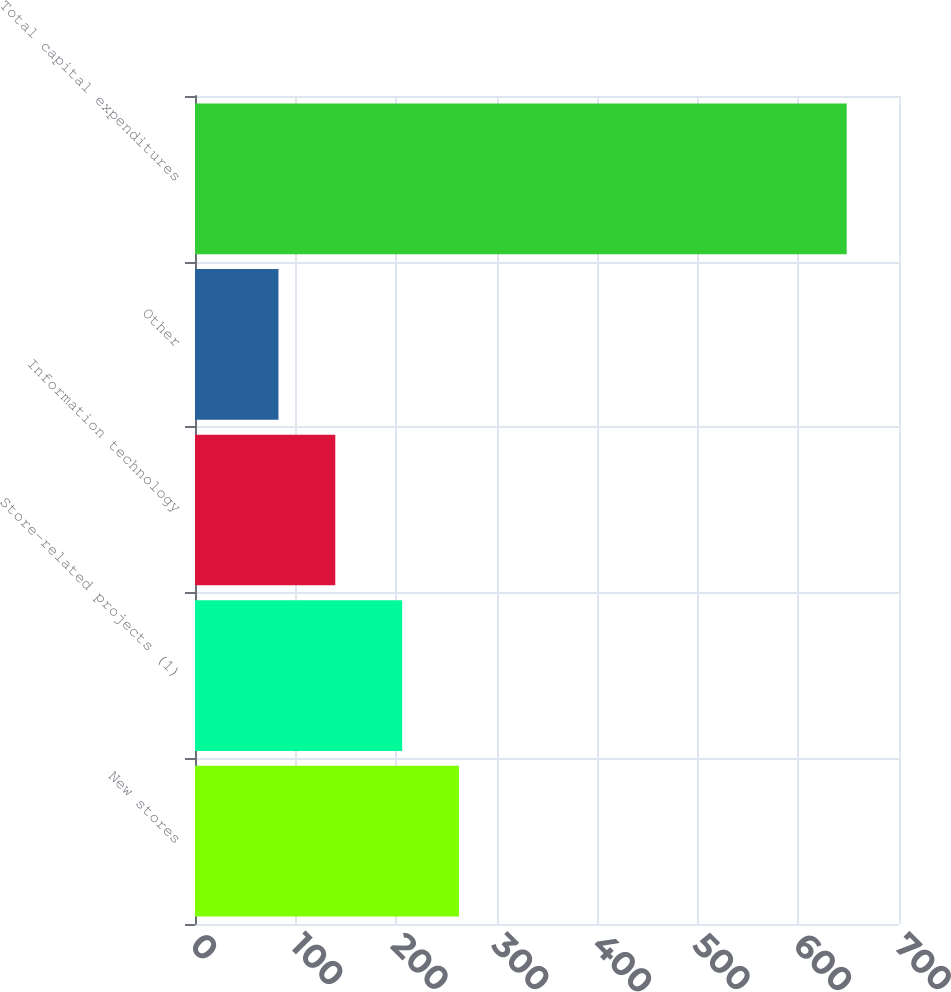Convert chart. <chart><loc_0><loc_0><loc_500><loc_500><bar_chart><fcel>New stores<fcel>Store-related projects (1)<fcel>Information technology<fcel>Other<fcel>Total capital expenditures<nl><fcel>262.5<fcel>206<fcel>139.5<fcel>83<fcel>648<nl></chart> 